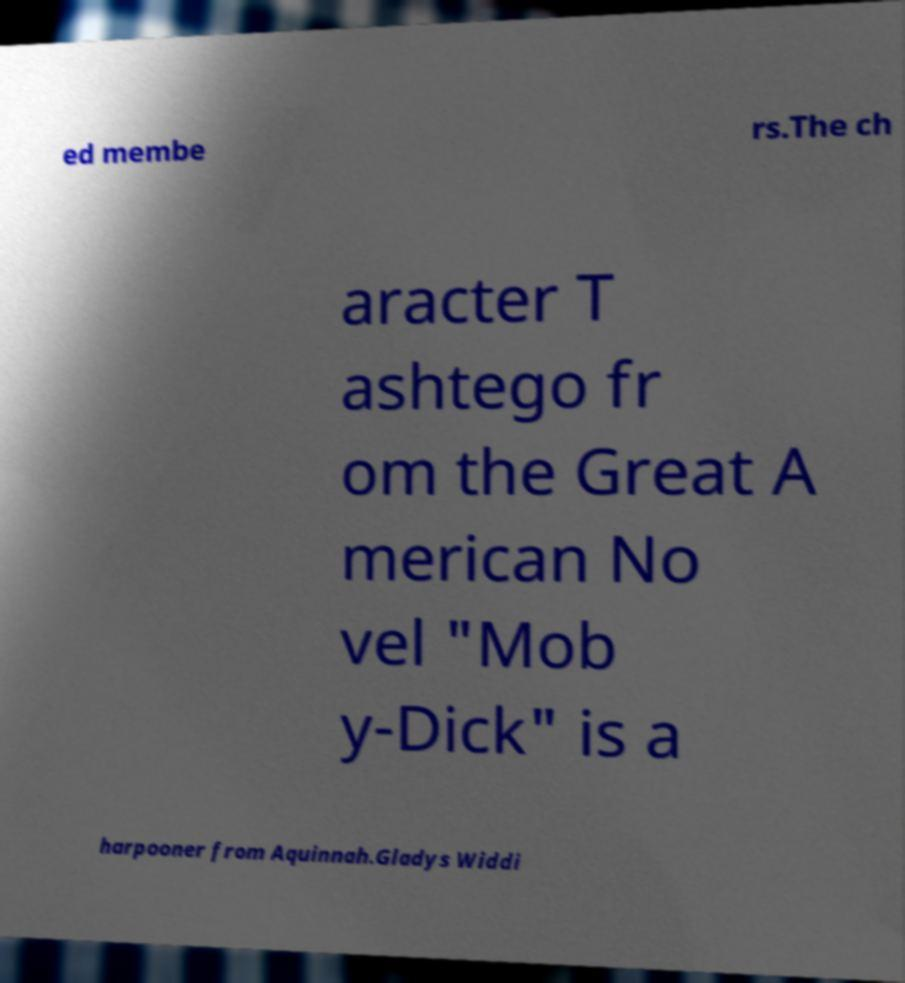Can you accurately transcribe the text from the provided image for me? ed membe rs.The ch aracter T ashtego fr om the Great A merican No vel "Mob y-Dick" is a harpooner from Aquinnah.Gladys Widdi 